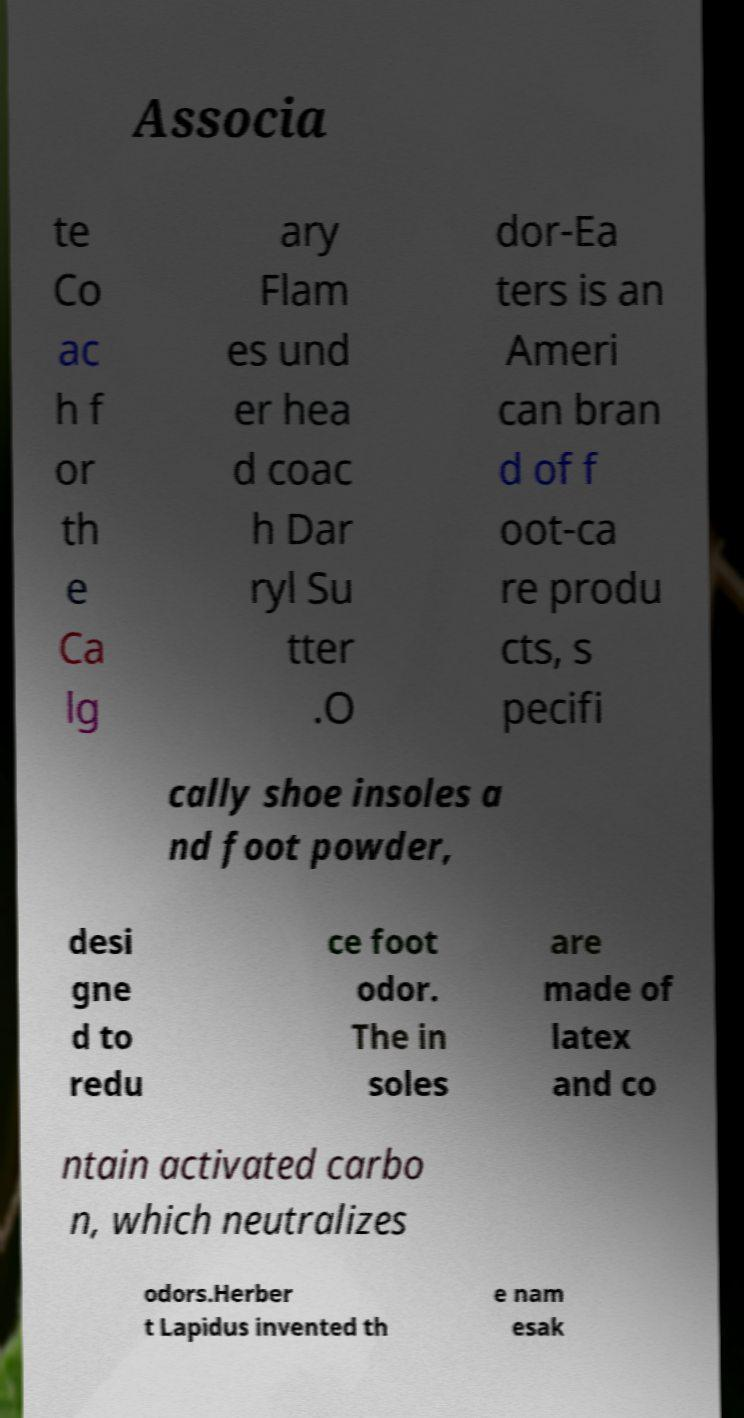What messages or text are displayed in this image? I need them in a readable, typed format. Associa te Co ac h f or th e Ca lg ary Flam es und er hea d coac h Dar ryl Su tter .O dor-Ea ters is an Ameri can bran d of f oot-ca re produ cts, s pecifi cally shoe insoles a nd foot powder, desi gne d to redu ce foot odor. The in soles are made of latex and co ntain activated carbo n, which neutralizes odors.Herber t Lapidus invented th e nam esak 